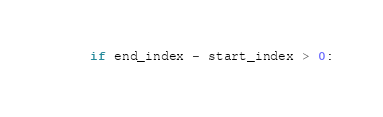<code> <loc_0><loc_0><loc_500><loc_500><_Python_>    if end_index - start_index > 0:</code> 